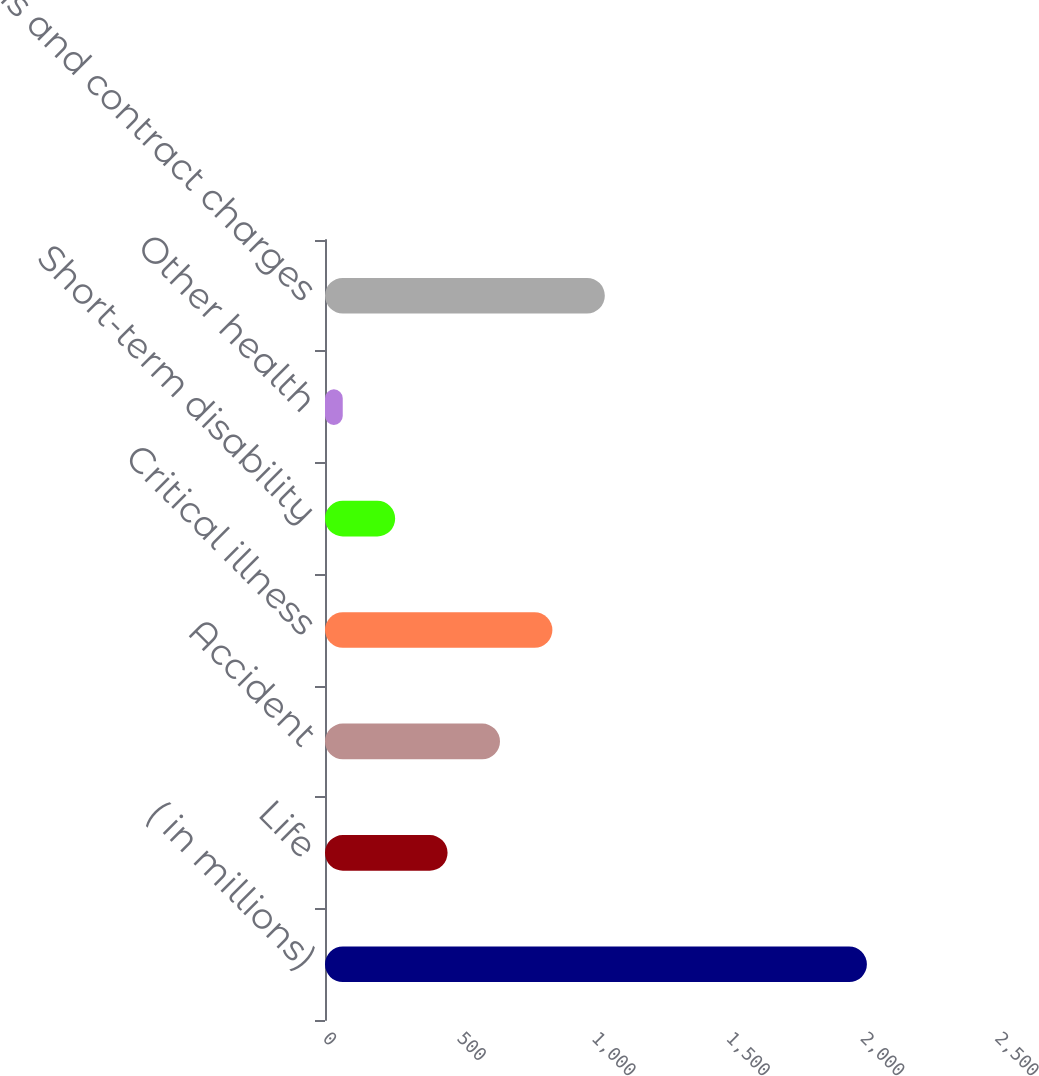<chart> <loc_0><loc_0><loc_500><loc_500><bar_chart><fcel>( in millions)<fcel>Life<fcel>Accident<fcel>Critical illness<fcel>Short-term disability<fcel>Other health<fcel>Premiums and contract charges<nl><fcel>2016<fcel>456<fcel>651<fcel>846<fcel>261<fcel>66<fcel>1041<nl></chart> 